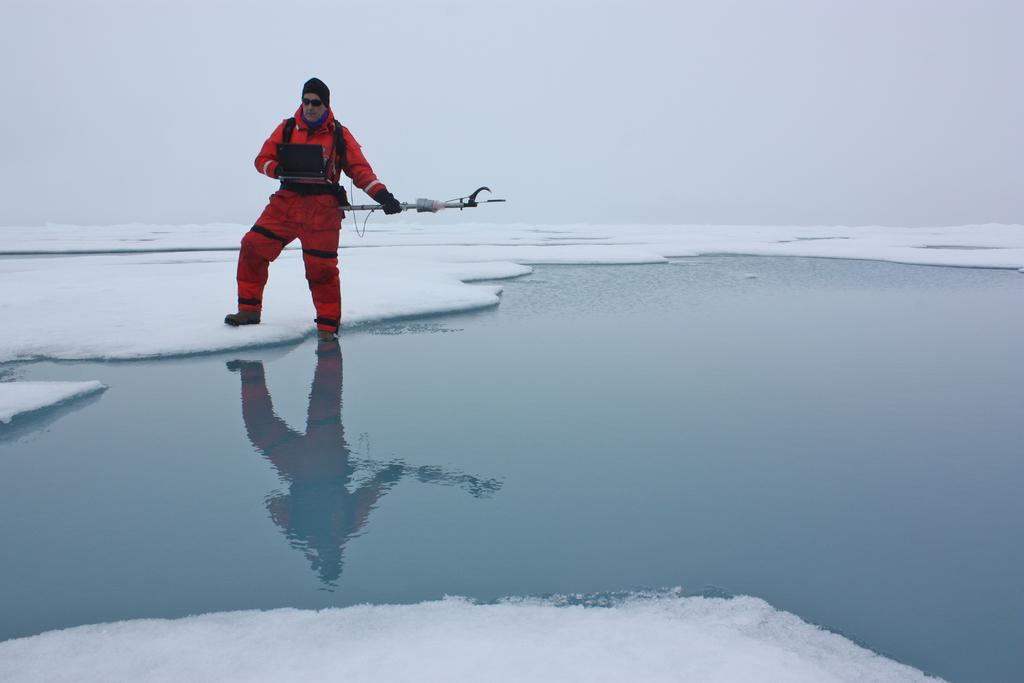Describe this image in one or two sentences. In this image there is a man standing. He is holding a stick in his hand. There is the snow and the water on the ground. At the top there is the sky. 